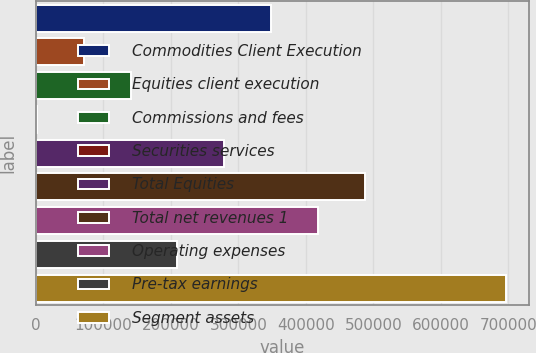Convert chart to OTSL. <chart><loc_0><loc_0><loc_500><loc_500><bar_chart><fcel>Commodities Client Execution<fcel>Equities client execution<fcel>Commissions and fees<fcel>Securities services<fcel>Total Equities<fcel>Total net revenues 1<fcel>Operating expenses<fcel>Pre-tax earnings<fcel>Segment assets<nl><fcel>348758<fcel>70954.9<fcel>140406<fcel>1504<fcel>279308<fcel>487660<fcel>418209<fcel>209857<fcel>696013<nl></chart> 